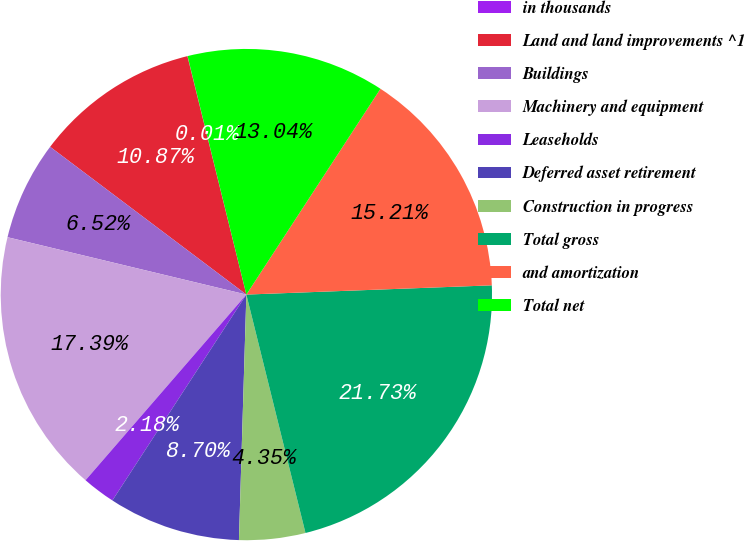Convert chart. <chart><loc_0><loc_0><loc_500><loc_500><pie_chart><fcel>in thousands<fcel>Land and land improvements ^1<fcel>Buildings<fcel>Machinery and equipment<fcel>Leaseholds<fcel>Deferred asset retirement<fcel>Construction in progress<fcel>Total gross<fcel>and amortization<fcel>Total net<nl><fcel>0.01%<fcel>10.87%<fcel>6.52%<fcel>17.39%<fcel>2.18%<fcel>8.7%<fcel>4.35%<fcel>21.73%<fcel>15.21%<fcel>13.04%<nl></chart> 